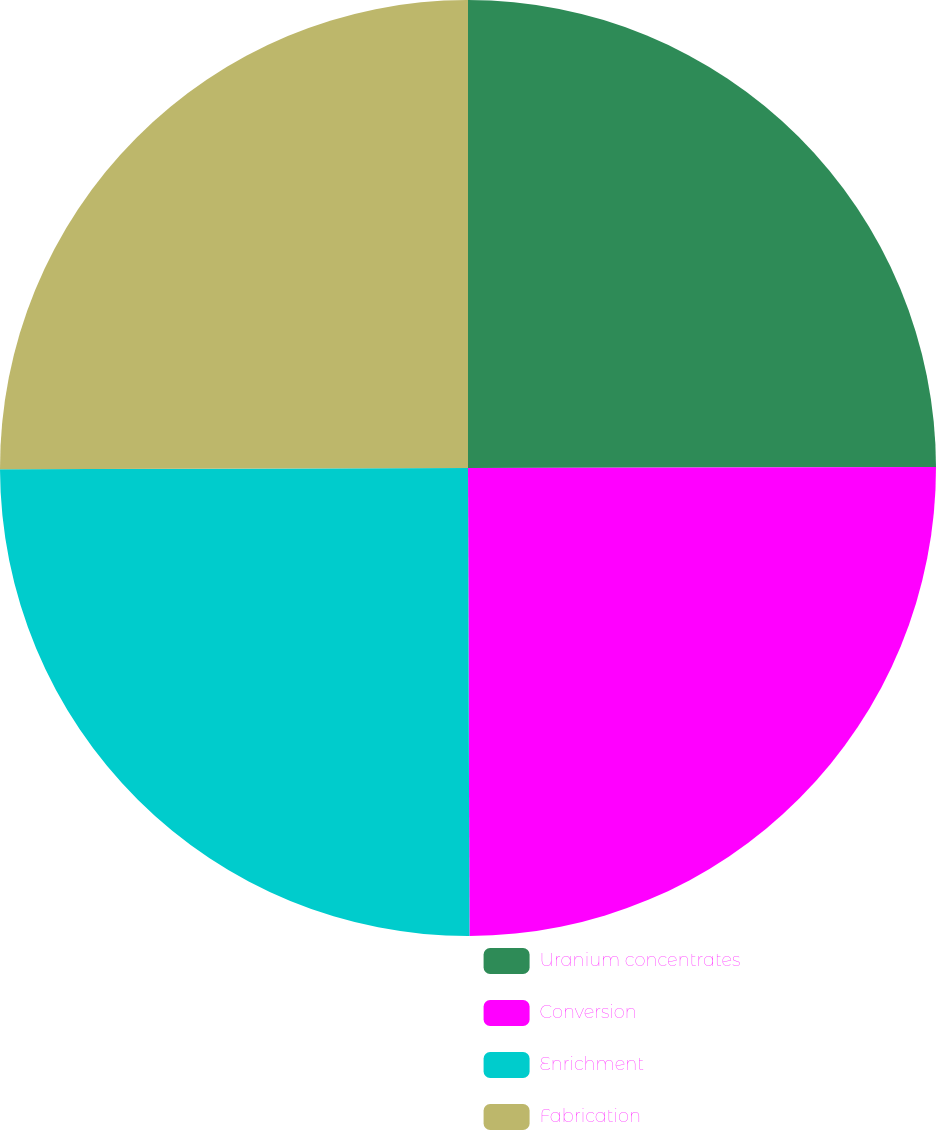Convert chart. <chart><loc_0><loc_0><loc_500><loc_500><pie_chart><fcel>Uranium concentrates<fcel>Conversion<fcel>Enrichment<fcel>Fabrication<nl><fcel>24.97%<fcel>24.98%<fcel>25.01%<fcel>25.04%<nl></chart> 